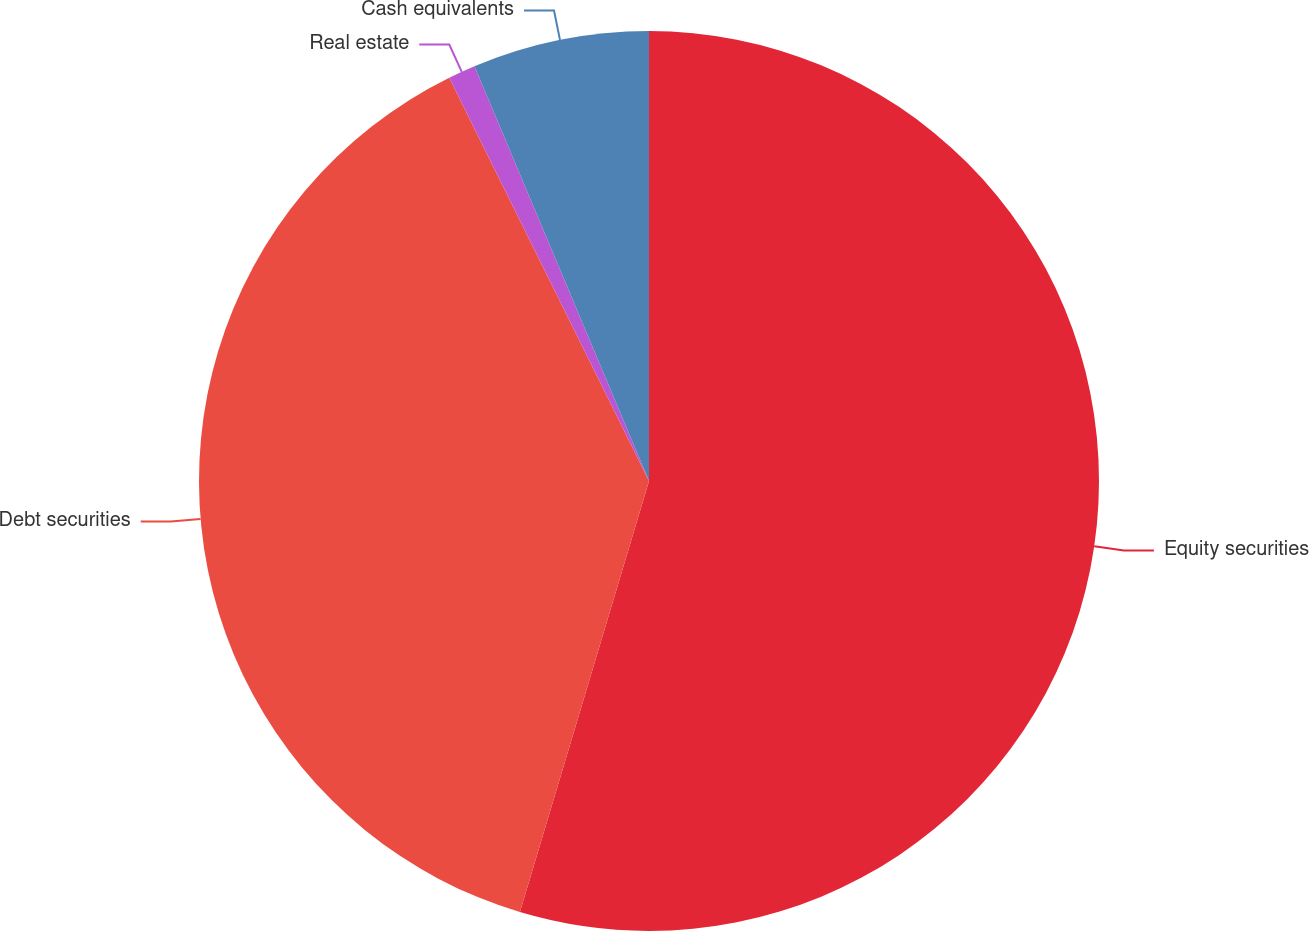<chart> <loc_0><loc_0><loc_500><loc_500><pie_chart><fcel>Equity securities<fcel>Debt securities<fcel>Real estate<fcel>Cash equivalents<nl><fcel>54.63%<fcel>38.05%<fcel>0.98%<fcel>6.34%<nl></chart> 